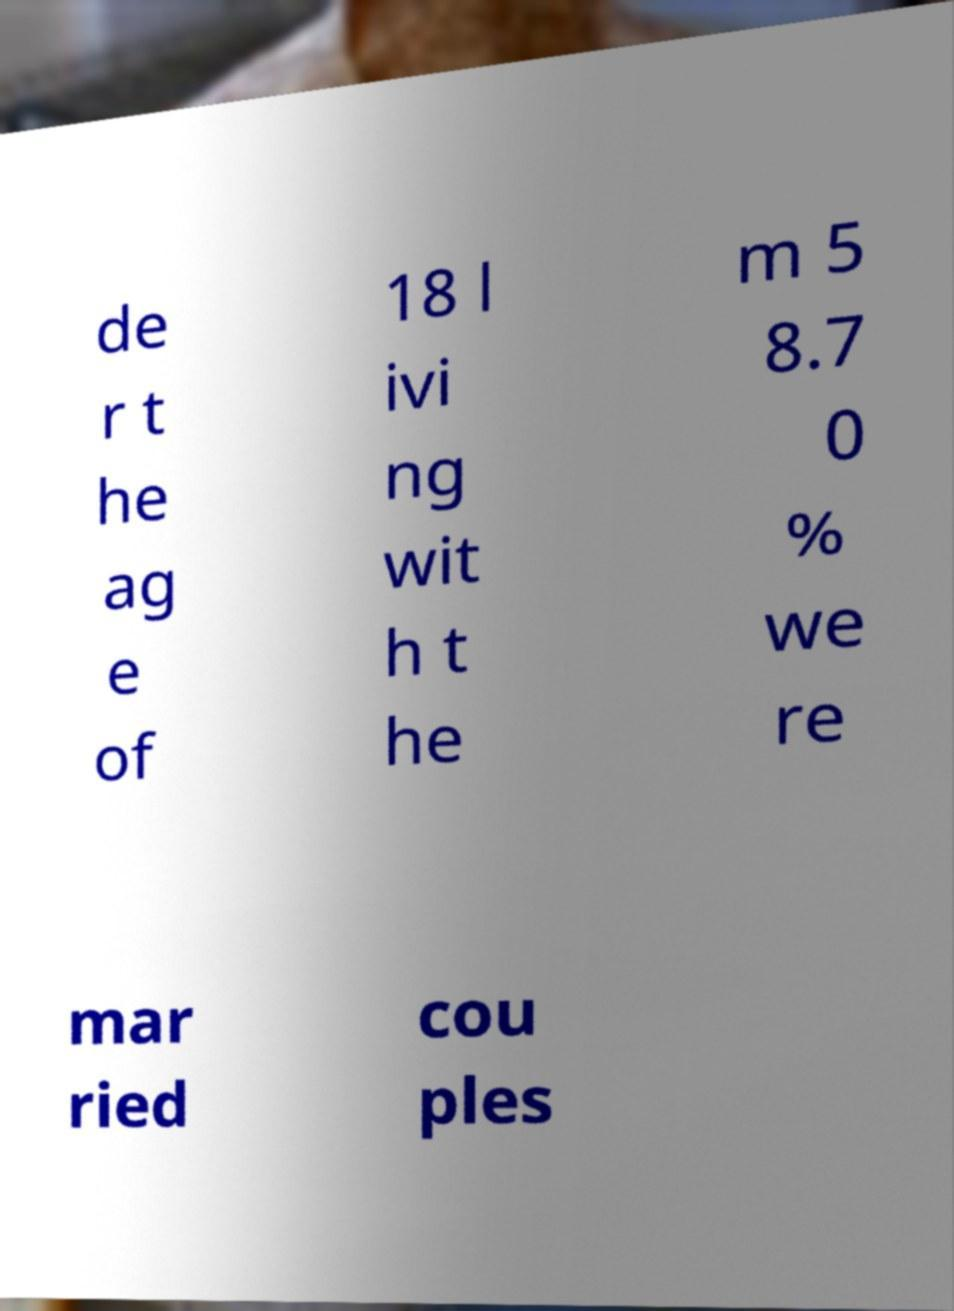For documentation purposes, I need the text within this image transcribed. Could you provide that? de r t he ag e of 18 l ivi ng wit h t he m 5 8.7 0 % we re mar ried cou ples 